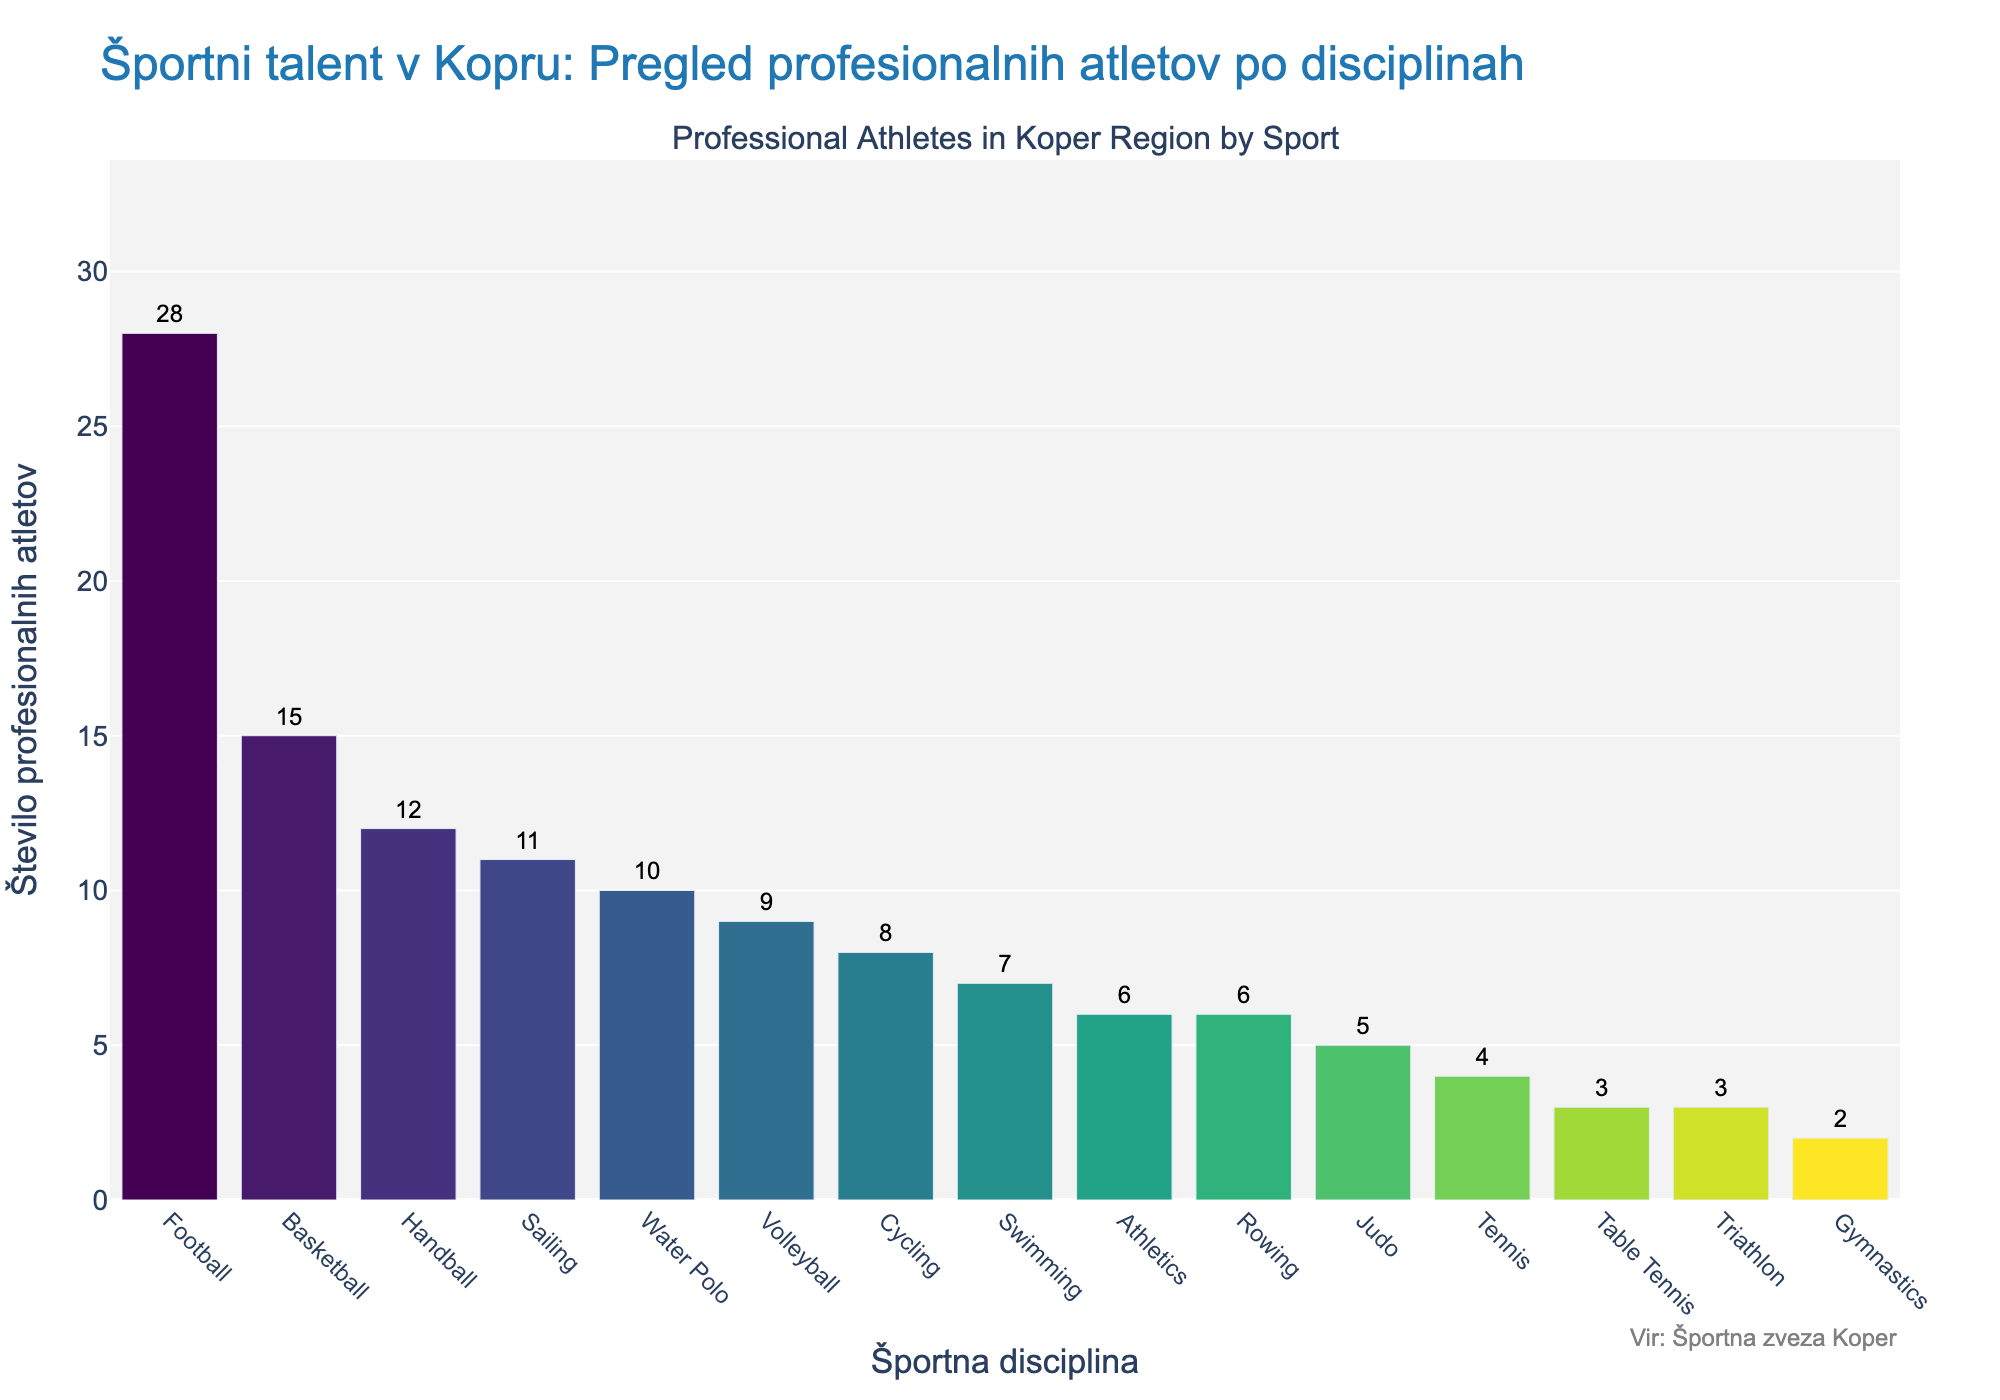Which sport has the highest number of professional athletes? Referring to the bar chart, the sport with the highest bar indicates the highest number of athletes. Football has the highest bar.
Answer: Football Which sport has the least number of professional athletes? The sport with the shortest bar in the chart indicates the least number of athletes. Gymnastics has the shortest bar.
Answer: Gymnastics How many professional athletes are there in Volleyball compared to Swimming? Look at the bar heights for Volleyball and Swimming. Volleyball has 9 and Swimming has 7 athletes.
Answer: Volleyball has 2 more athletes than Swimming What is the total number of professional athletes in Football, Basketball, and Handball combined? Add the number of athletes in these three sports: Football (28), Basketball (15), Handball (12). So, 28 + 15 + 12 = 55.
Answer: 55 What is the difference in the number of professional athletes between the sport with the most and the sport with the least athletes? The sport with the most athletes is Football (28), and the sport with the least is Gymnastics (2). The difference is 28 - 2 = 26.
Answer: 26 How many more athletes are there in Football than in Tennis? Football has 28 athletes and Tennis has 4 athletes. The difference is 28 - 4 = 24.
Answer: 24 Which sport has a higher number of professional athletes: Rowing or Athletics? Compare the bar heights for Rowing and Athletics. Rowing has 6 athletes and Athletics also has 6.
Answer: They have the same number of athletes If we combine the number of athletes in Cycling and Water Polo, what total do we get? Add the athletes in Cycling and Water Polo: Cycling (8) + Water Polo (10). So, 8 + 10 = 18.
Answer: 18 Which two sports have the closest number of professional athletes and what is that number? Look for bars of similar heights. Rowing and Athletics both have 6 athletes.
Answer: Rowing and Athletics have 6 athletes each What is the average number of professional athletes across all sports listed? Sum all the data points and divide by the number of sports: (28+15+12+9+7+11+6+4+8+10+5+6+3+2+3) = 129. There are 15 sports, so the average is 129 / 15 = 8.6.
Answer: 8.6 